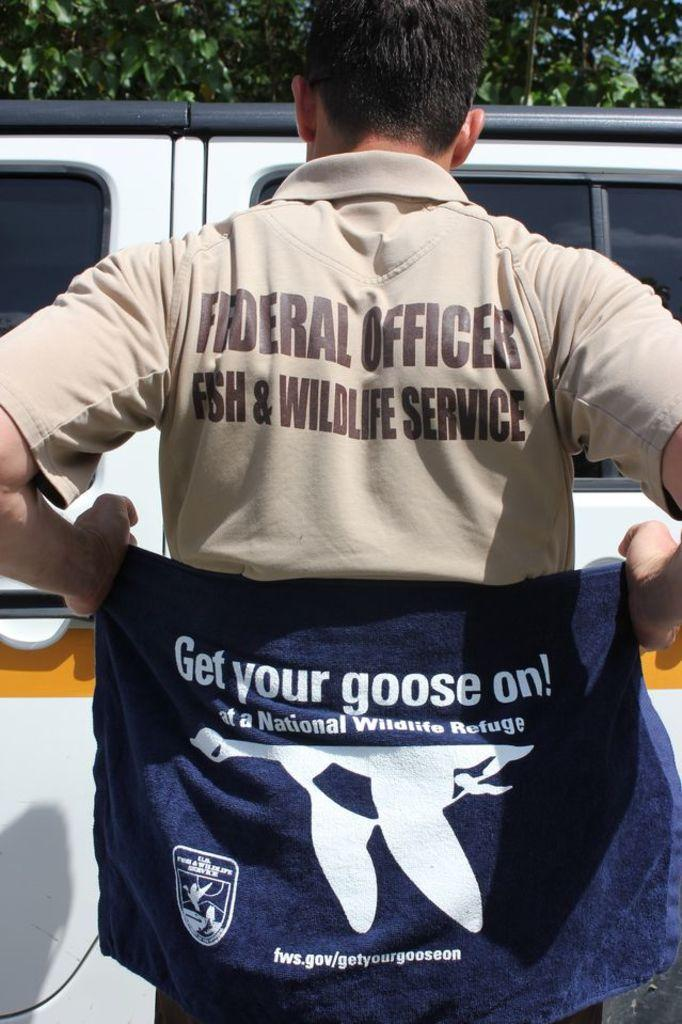<image>
Write a terse but informative summary of the picture. a shirt with the word goose on it 